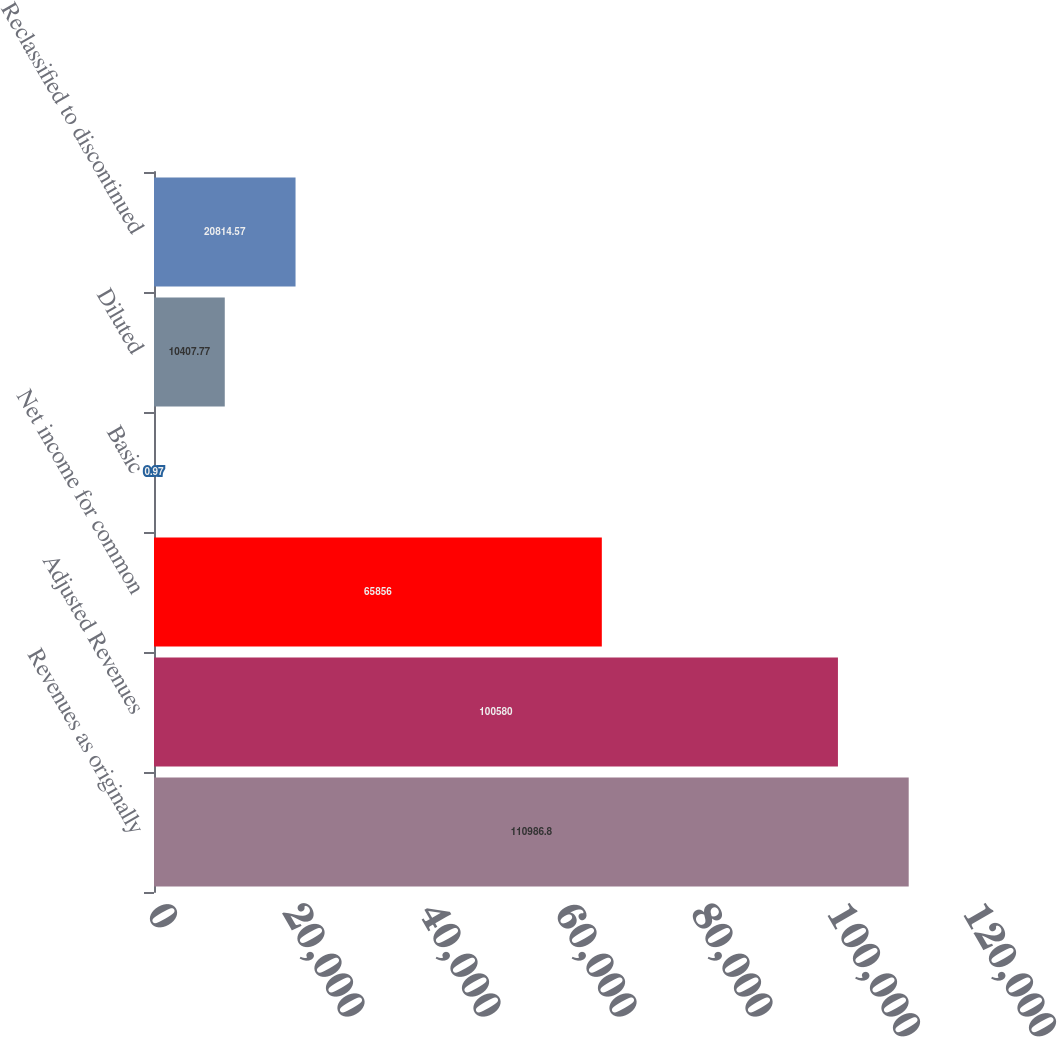<chart> <loc_0><loc_0><loc_500><loc_500><bar_chart><fcel>Revenues as originally<fcel>Adjusted Revenues<fcel>Net income for common<fcel>Basic<fcel>Diluted<fcel>Reclassified to discontinued<nl><fcel>110987<fcel>100580<fcel>65856<fcel>0.97<fcel>10407.8<fcel>20814.6<nl></chart> 